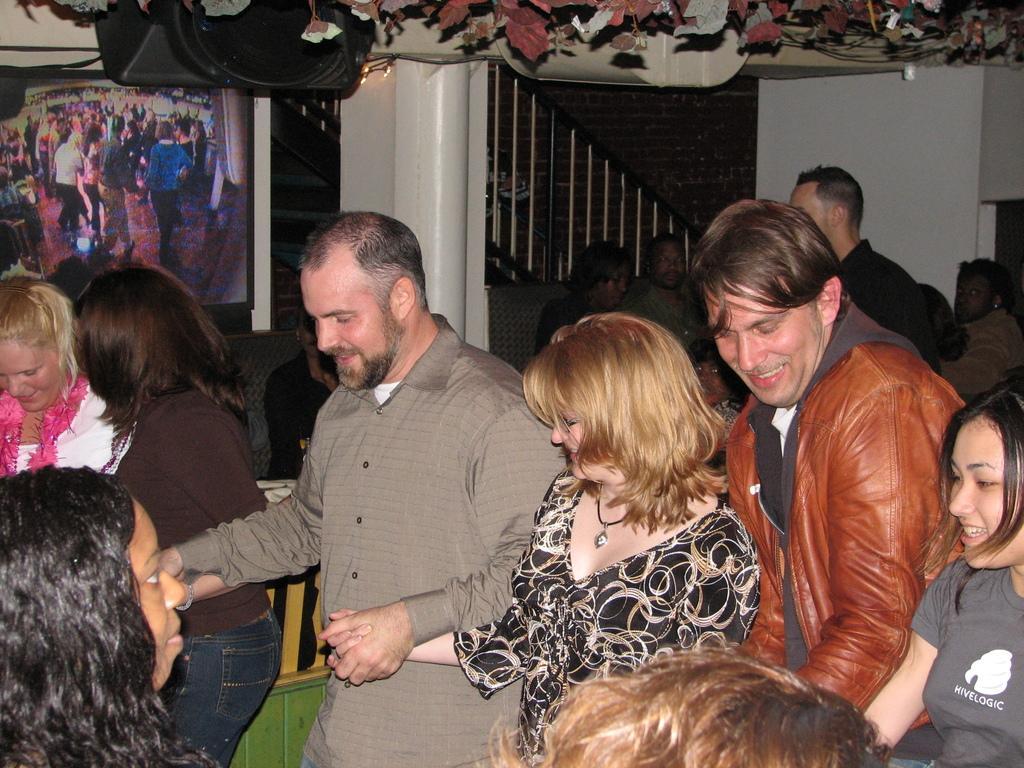Can you describe this image briefly? In this image we can see men and women are holding their hand and dancing. In the background, we can see the pillar, railing, screen and people. At the top of the image, we can see leaves, lights and one black color object. 